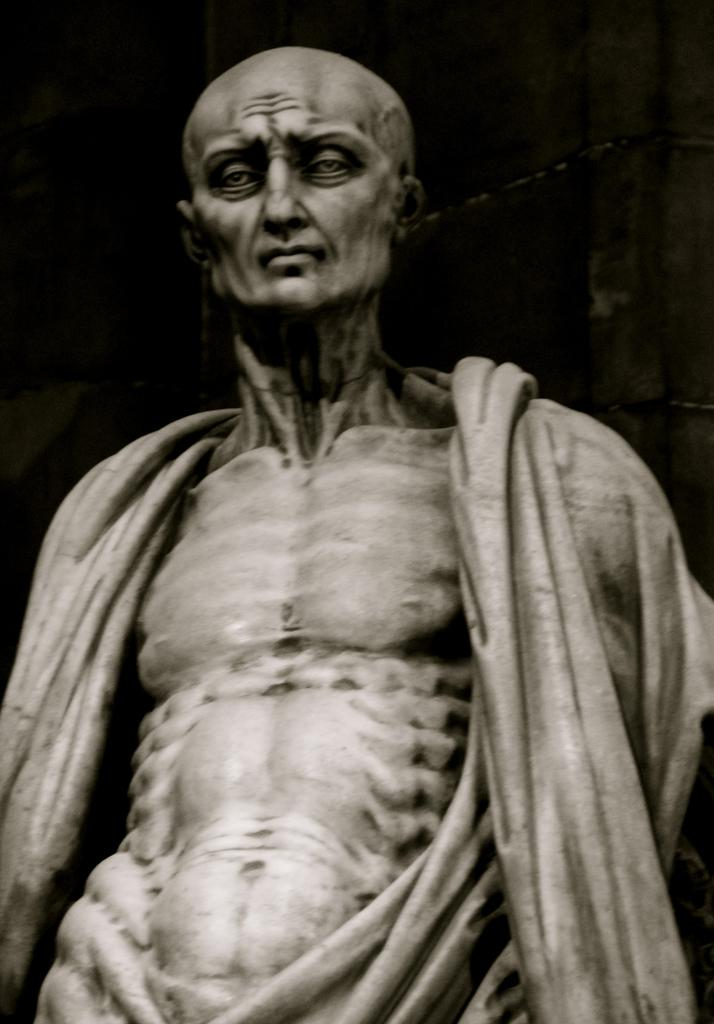What is the main subject of the image? There is a sculpture in the center of the image. What can be observed in the background of the image? The background of the image is dark. What type of celery is being used to decorate the sculpture in the image? There is no celery present in the image; it features a sculpture with a dark background. 